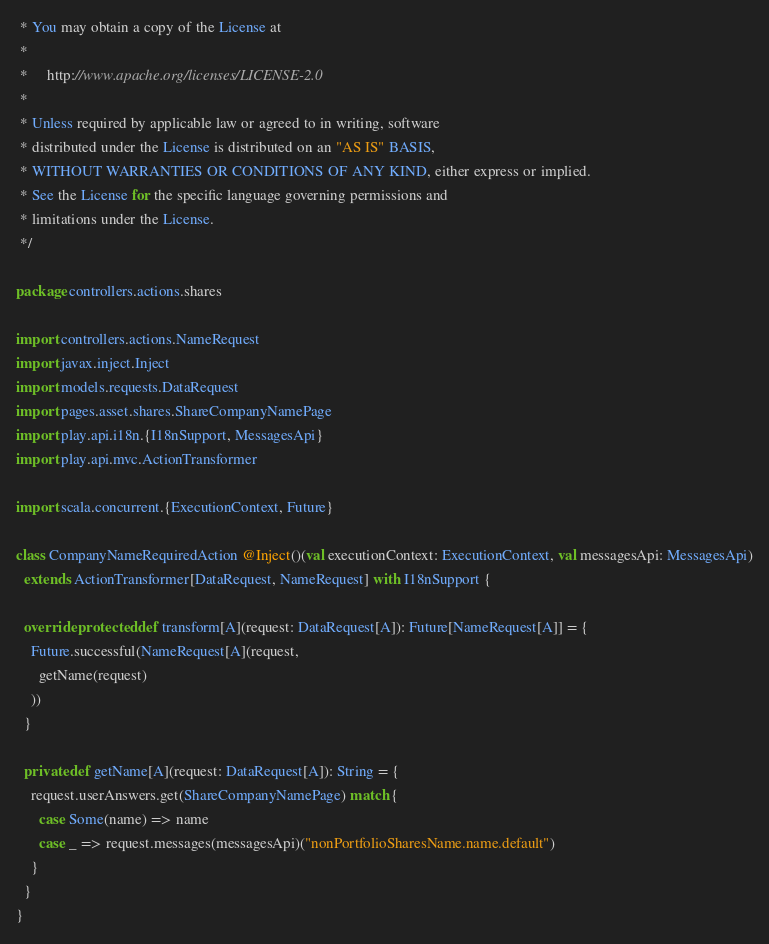Convert code to text. <code><loc_0><loc_0><loc_500><loc_500><_Scala_> * You may obtain a copy of the License at
 *
 *     http://www.apache.org/licenses/LICENSE-2.0
 *
 * Unless required by applicable law or agreed to in writing, software
 * distributed under the License is distributed on an "AS IS" BASIS,
 * WITHOUT WARRANTIES OR CONDITIONS OF ANY KIND, either express or implied.
 * See the License for the specific language governing permissions and
 * limitations under the License.
 */

package controllers.actions.shares

import controllers.actions.NameRequest
import javax.inject.Inject
import models.requests.DataRequest
import pages.asset.shares.ShareCompanyNamePage
import play.api.i18n.{I18nSupport, MessagesApi}
import play.api.mvc.ActionTransformer

import scala.concurrent.{ExecutionContext, Future}

class CompanyNameRequiredAction @Inject()(val executionContext: ExecutionContext, val messagesApi: MessagesApi)
  extends ActionTransformer[DataRequest, NameRequest] with I18nSupport {

  override protected def transform[A](request: DataRequest[A]): Future[NameRequest[A]] = {
    Future.successful(NameRequest[A](request,
      getName(request)
    ))
  }

  private def getName[A](request: DataRequest[A]): String = {
    request.userAnswers.get(ShareCompanyNamePage) match {
      case Some(name) => name
      case _ => request.messages(messagesApi)("nonPortfolioSharesName.name.default")
    }
  }
}
</code> 